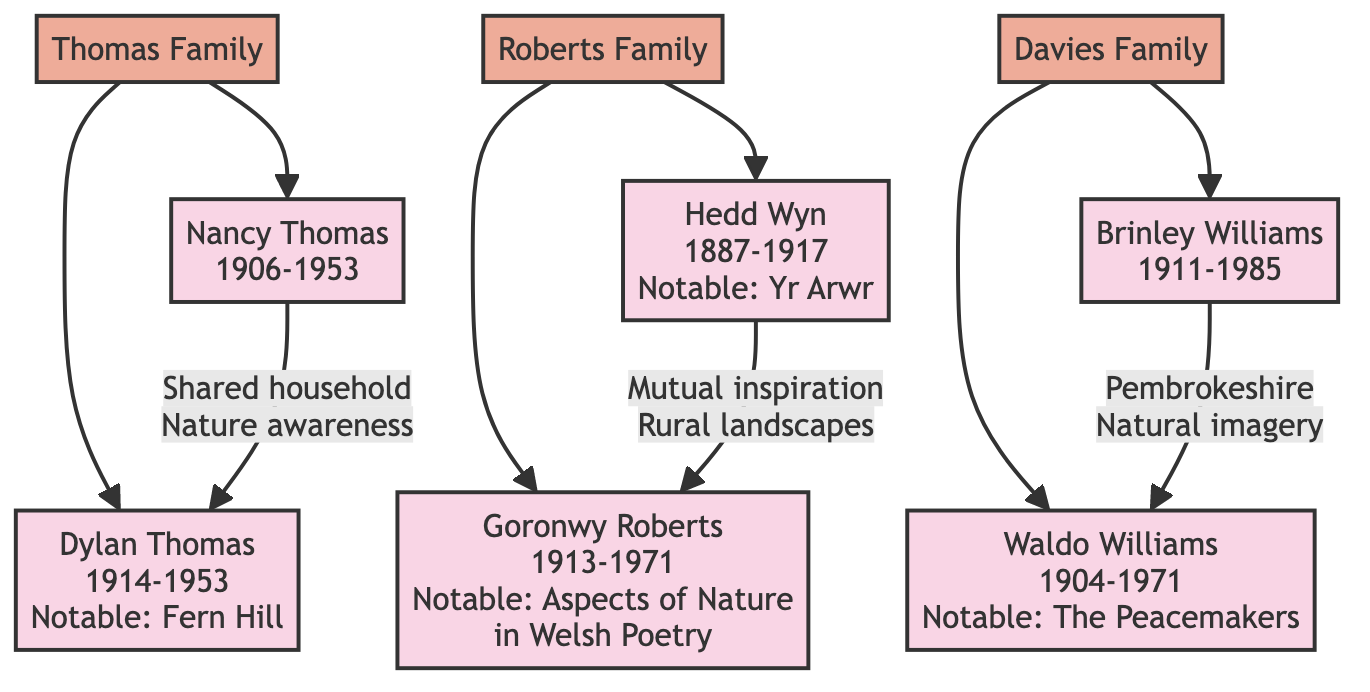What is the birth year of Dylan Thomas? The diagram indicates that Dylan Thomas was born in 1914, which is clearly stated next to his name in the family tree.
Answer: 1914 Who is the sister of Dylan Thomas? The diagram specifies that Nancy Thomas is identified as the sister of Dylan Thomas, directly connected to him in the family tree.
Answer: Nancy Thomas How many poets are in the Roberts family? There are two poets in the Roberts family, as indicated by the two members listed under the Roberts family section in the diagram.
Answer: 2 What relation is Hedd Wyn to Goronwy Roberts? Hedd Wyn is indicated as a cousin of Goronwy Roberts in the family tree, which shows their relation clearly.
Answer: cousin What influence did Nancy Thomas have on Dylan Thomas? The diagram notes that Nancy Thomas's influence on Dylan was due to their shared household and upbringing, contributing to his awareness of nature.
Answer: Shared household and upbringing Which poet’s works focus on the natural imagery inspired by childhood in Pembrokeshire? The diagram indicates that both Waldo Williams and Brinley Williams drew from their childhood in Pembrokeshire for natural imagery, but specifically asks for their works.
Answer: Waldo Williams What notable work did Hedd Wyn create? The diagram states that Hedd Wyn's notable work is "Yr Arwr," which is mentioned next to his name in the family tree.
Answer: Yr Arwr What year did Goronwy Roberts pass away? Referring to the diagram, Goronwy Roberts died in 1971, a detail indicated alongside his name.
Answer: 1971 How many families are represented in the diagram? The diagram reflects three families; the Thomas family, the Roberts family, and the Davies family, as detailed at the start of the family tree.
Answer: 3 